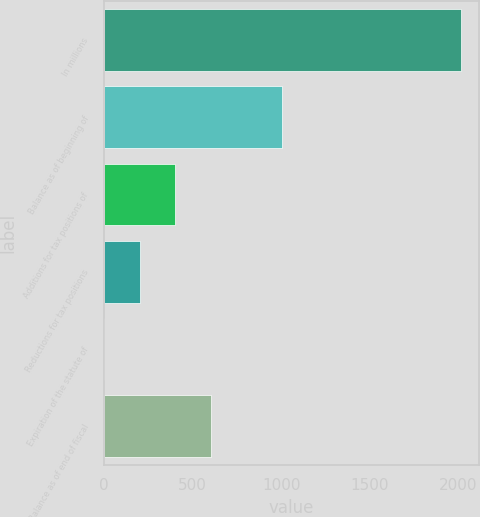Convert chart. <chart><loc_0><loc_0><loc_500><loc_500><bar_chart><fcel>In millions<fcel>Balance as of beginning of<fcel>Additions for tax positions of<fcel>Reductions for tax positions<fcel>Expiration of the statute of<fcel>Balance as of end of fiscal<nl><fcel>2013<fcel>1006.6<fcel>402.76<fcel>201.48<fcel>0.2<fcel>604.04<nl></chart> 